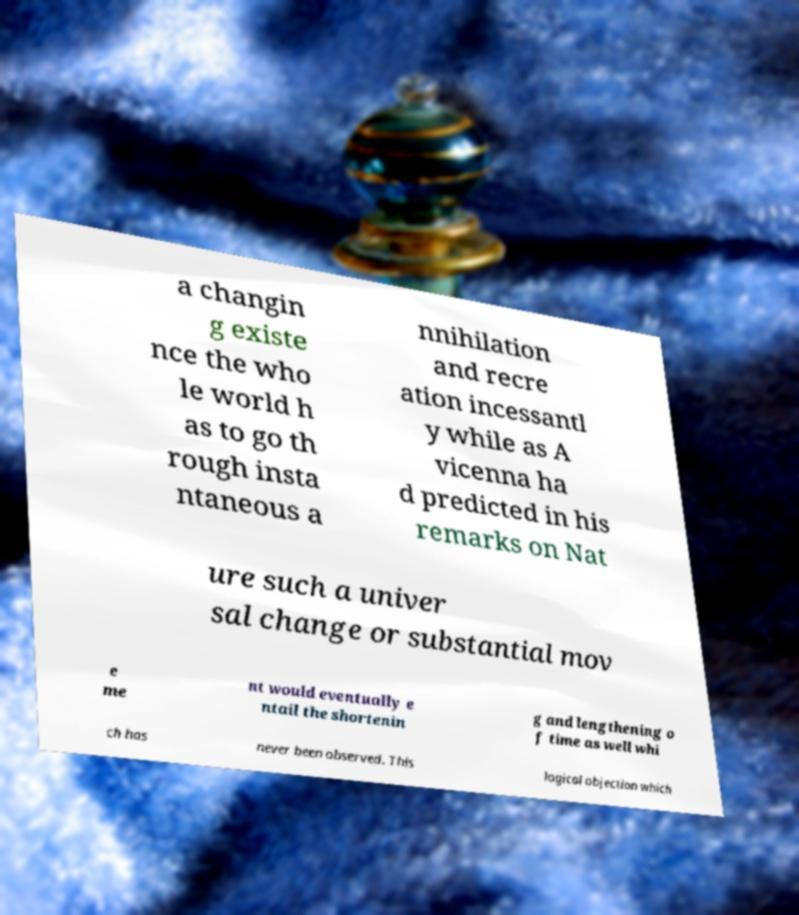Can you accurately transcribe the text from the provided image for me? a changin g existe nce the who le world h as to go th rough insta ntaneous a nnihilation and recre ation incessantl y while as A vicenna ha d predicted in his remarks on Nat ure such a univer sal change or substantial mov e me nt would eventually e ntail the shortenin g and lengthening o f time as well whi ch has never been observed. This logical objection which 